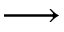<formula> <loc_0><loc_0><loc_500><loc_500>\longrightarrow</formula> 